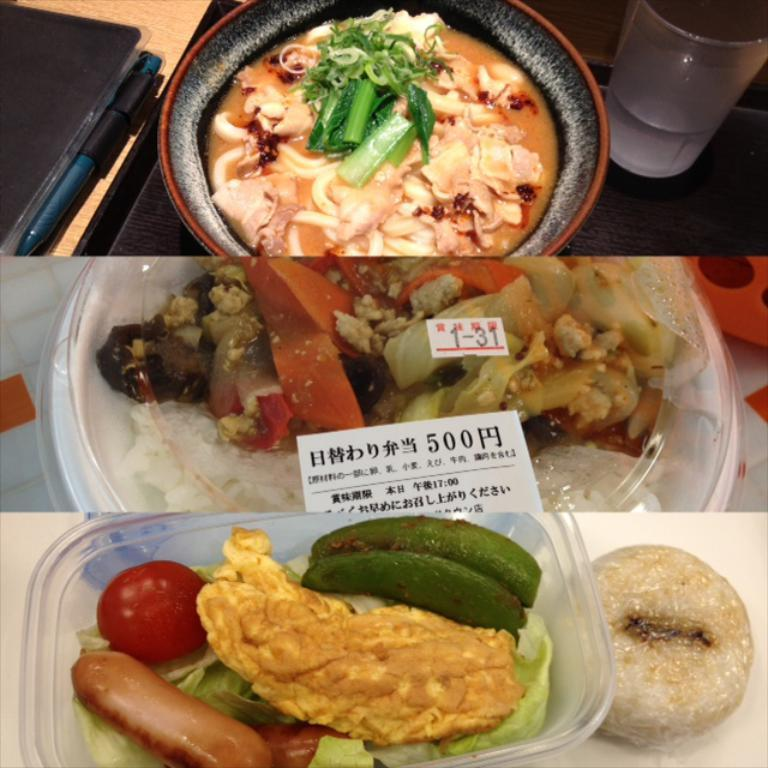What type of items can be seen in the image? The image contains food, bowls, and a glass with a drink. How many bowls are visible in the image? There are bowls in the image, but the exact number is not specified. What is in the glass that is visible in the image? There is a drink in the glass that is visible in the image. Can you describe the unspecified objects in the image? Unfortunately, the provided facts do not give any information about the unspecified objects in the image. What type of vegetable is being used as a reason for the truck's breakdown in the image? There is no vegetable, reason, or truck present in the image. 